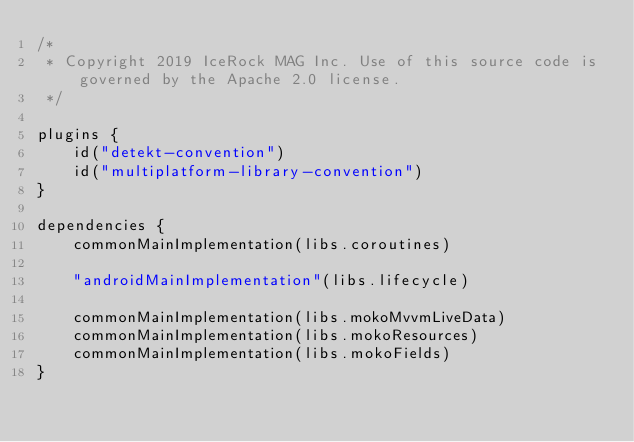<code> <loc_0><loc_0><loc_500><loc_500><_Kotlin_>/*
 * Copyright 2019 IceRock MAG Inc. Use of this source code is governed by the Apache 2.0 license.
 */

plugins {
    id("detekt-convention")
    id("multiplatform-library-convention")
}

dependencies {
    commonMainImplementation(libs.coroutines)

    "androidMainImplementation"(libs.lifecycle)

    commonMainImplementation(libs.mokoMvvmLiveData)
    commonMainImplementation(libs.mokoResources)
    commonMainImplementation(libs.mokoFields)
}
</code> 